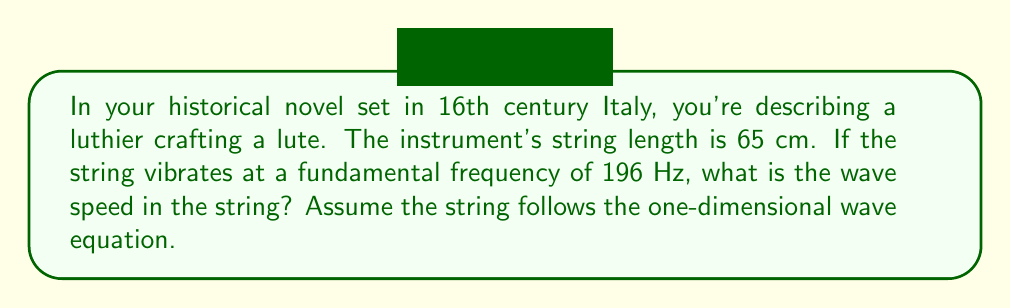Solve this math problem. Let's approach this step-by-step using the wave equation:

1) The one-dimensional wave equation is given by:

   $$\frac{\partial^2 y}{\partial t^2} = v^2 \frac{\partial^2 y}{\partial x^2}$$

   where $v$ is the wave speed we're looking for.

2) For a string fixed at both ends, the fundamental frequency $f$ is related to the string length $L$ and wave speed $v$ by:

   $$f = \frac{v}{2L}$$

3) We can rearrange this equation to solve for $v$:

   $$v = 2Lf$$

4) Now, let's substitute our known values:
   $L = 65$ cm $= 0.65$ m
   $f = 196$ Hz

5) Calculating:

   $$v = 2 \cdot 0.65 \text{ m} \cdot 196 \text{ Hz} = 254.8 \text{ m/s}$$

Thus, the wave speed in the lute string is approximately 254.8 m/s.
Answer: 254.8 m/s 